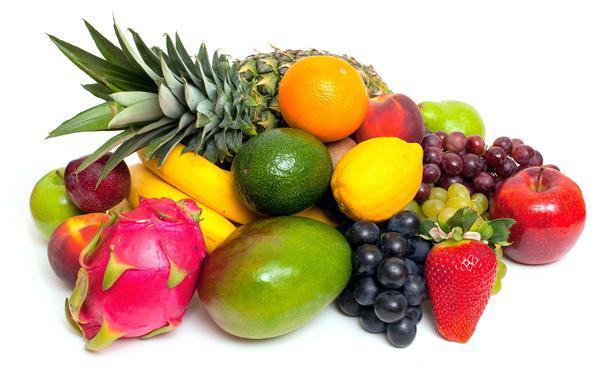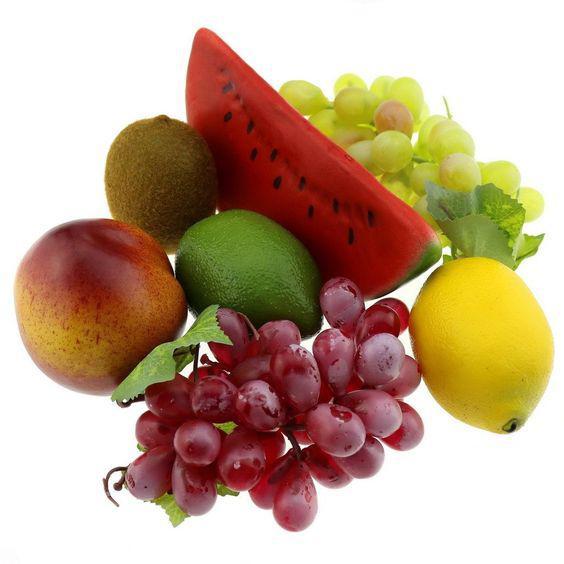The first image is the image on the left, the second image is the image on the right. Evaluate the accuracy of this statement regarding the images: "An image contains two intact peaches, plus a whole lemon next to part of a lemon.". Is it true? Answer yes or no. No. 